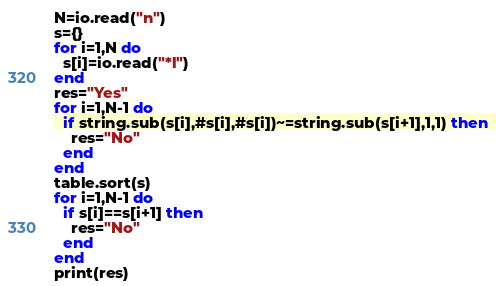Convert code to text. <code><loc_0><loc_0><loc_500><loc_500><_Lua_>N=io.read("n")
s={}
for i=1,N do 
  s[i]=io.read("*l")
end
res="Yes"
for i=1,N-1 do
  if string.sub(s[i],#s[i],#s[i])~=string.sub(s[i+1],1,1) then
    res="No"
  end
end
table.sort(s)
for i=1,N-1 do
  if s[i]==s[i+1] then
    res="No"
  end
end
print(res)
</code> 